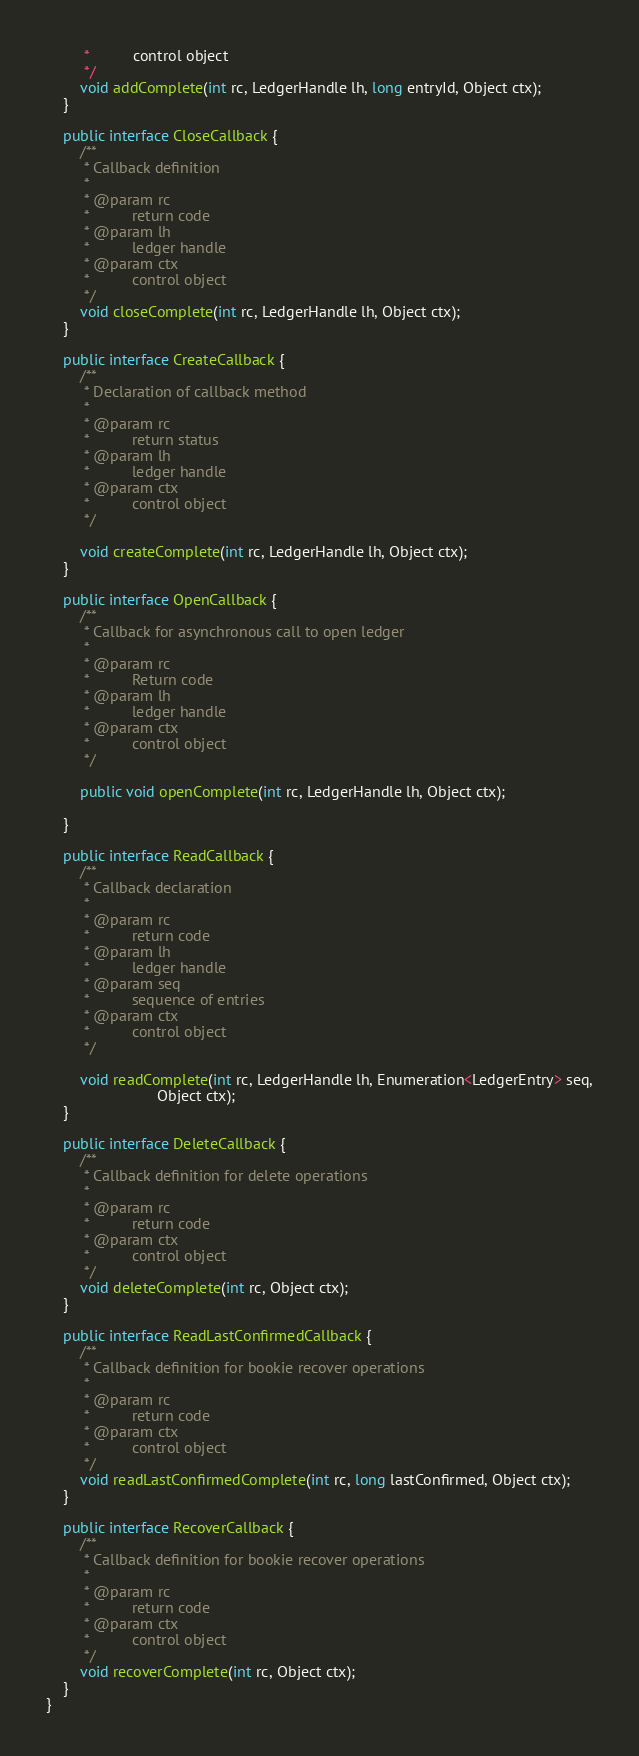Convert code to text. <code><loc_0><loc_0><loc_500><loc_500><_Java_>         *          control object
         */
        void addComplete(int rc, LedgerHandle lh, long entryId, Object ctx);
    }

    public interface CloseCallback {
        /**
         * Callback definition
         *
         * @param rc
         *          return code
         * @param lh
         *          ledger handle
         * @param ctx
         *          control object
         */
        void closeComplete(int rc, LedgerHandle lh, Object ctx);
    }

    public interface CreateCallback {
        /**
         * Declaration of callback method
         *
         * @param rc
         *          return status
         * @param lh
         *          ledger handle
         * @param ctx
         *          control object
         */

        void createComplete(int rc, LedgerHandle lh, Object ctx);
    }

    public interface OpenCallback {
        /**
         * Callback for asynchronous call to open ledger
         *
         * @param rc
         *          Return code
         * @param lh
         *          ledger handle
         * @param ctx
         *          control object
         */

        public void openComplete(int rc, LedgerHandle lh, Object ctx);

    }

    public interface ReadCallback {
        /**
         * Callback declaration
         *
         * @param rc
         *          return code
         * @param lh
         *          ledger handle
         * @param seq
         *          sequence of entries
         * @param ctx
         *          control object
         */

        void readComplete(int rc, LedgerHandle lh, Enumeration<LedgerEntry> seq,
                          Object ctx);
    }

    public interface DeleteCallback {
        /**
         * Callback definition for delete operations
         *
         * @param rc
         *          return code
         * @param ctx
         *          control object
         */
        void deleteComplete(int rc, Object ctx);
    }

    public interface ReadLastConfirmedCallback {
        /**
         * Callback definition for bookie recover operations
         *
         * @param rc
         *          return code
         * @param ctx
         *          control object
         */
        void readLastConfirmedComplete(int rc, long lastConfirmed, Object ctx);
    }

    public interface RecoverCallback {
        /**
         * Callback definition for bookie recover operations
         *
         * @param rc
         *          return code
         * @param ctx
         *          control object
         */
        void recoverComplete(int rc, Object ctx);
    }
}
</code> 